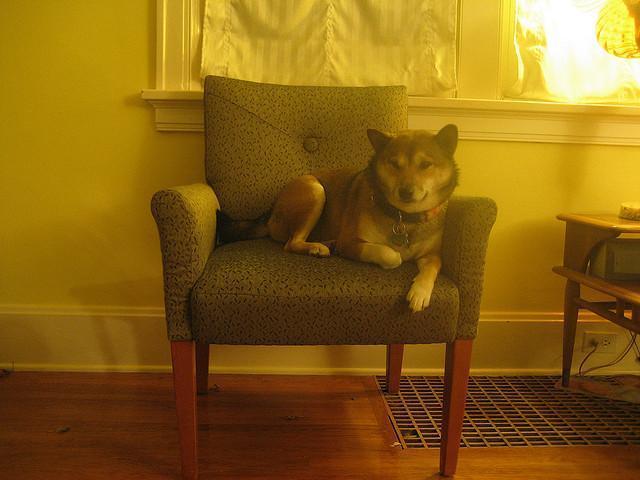How many dogs are visible?
Give a very brief answer. 1. 